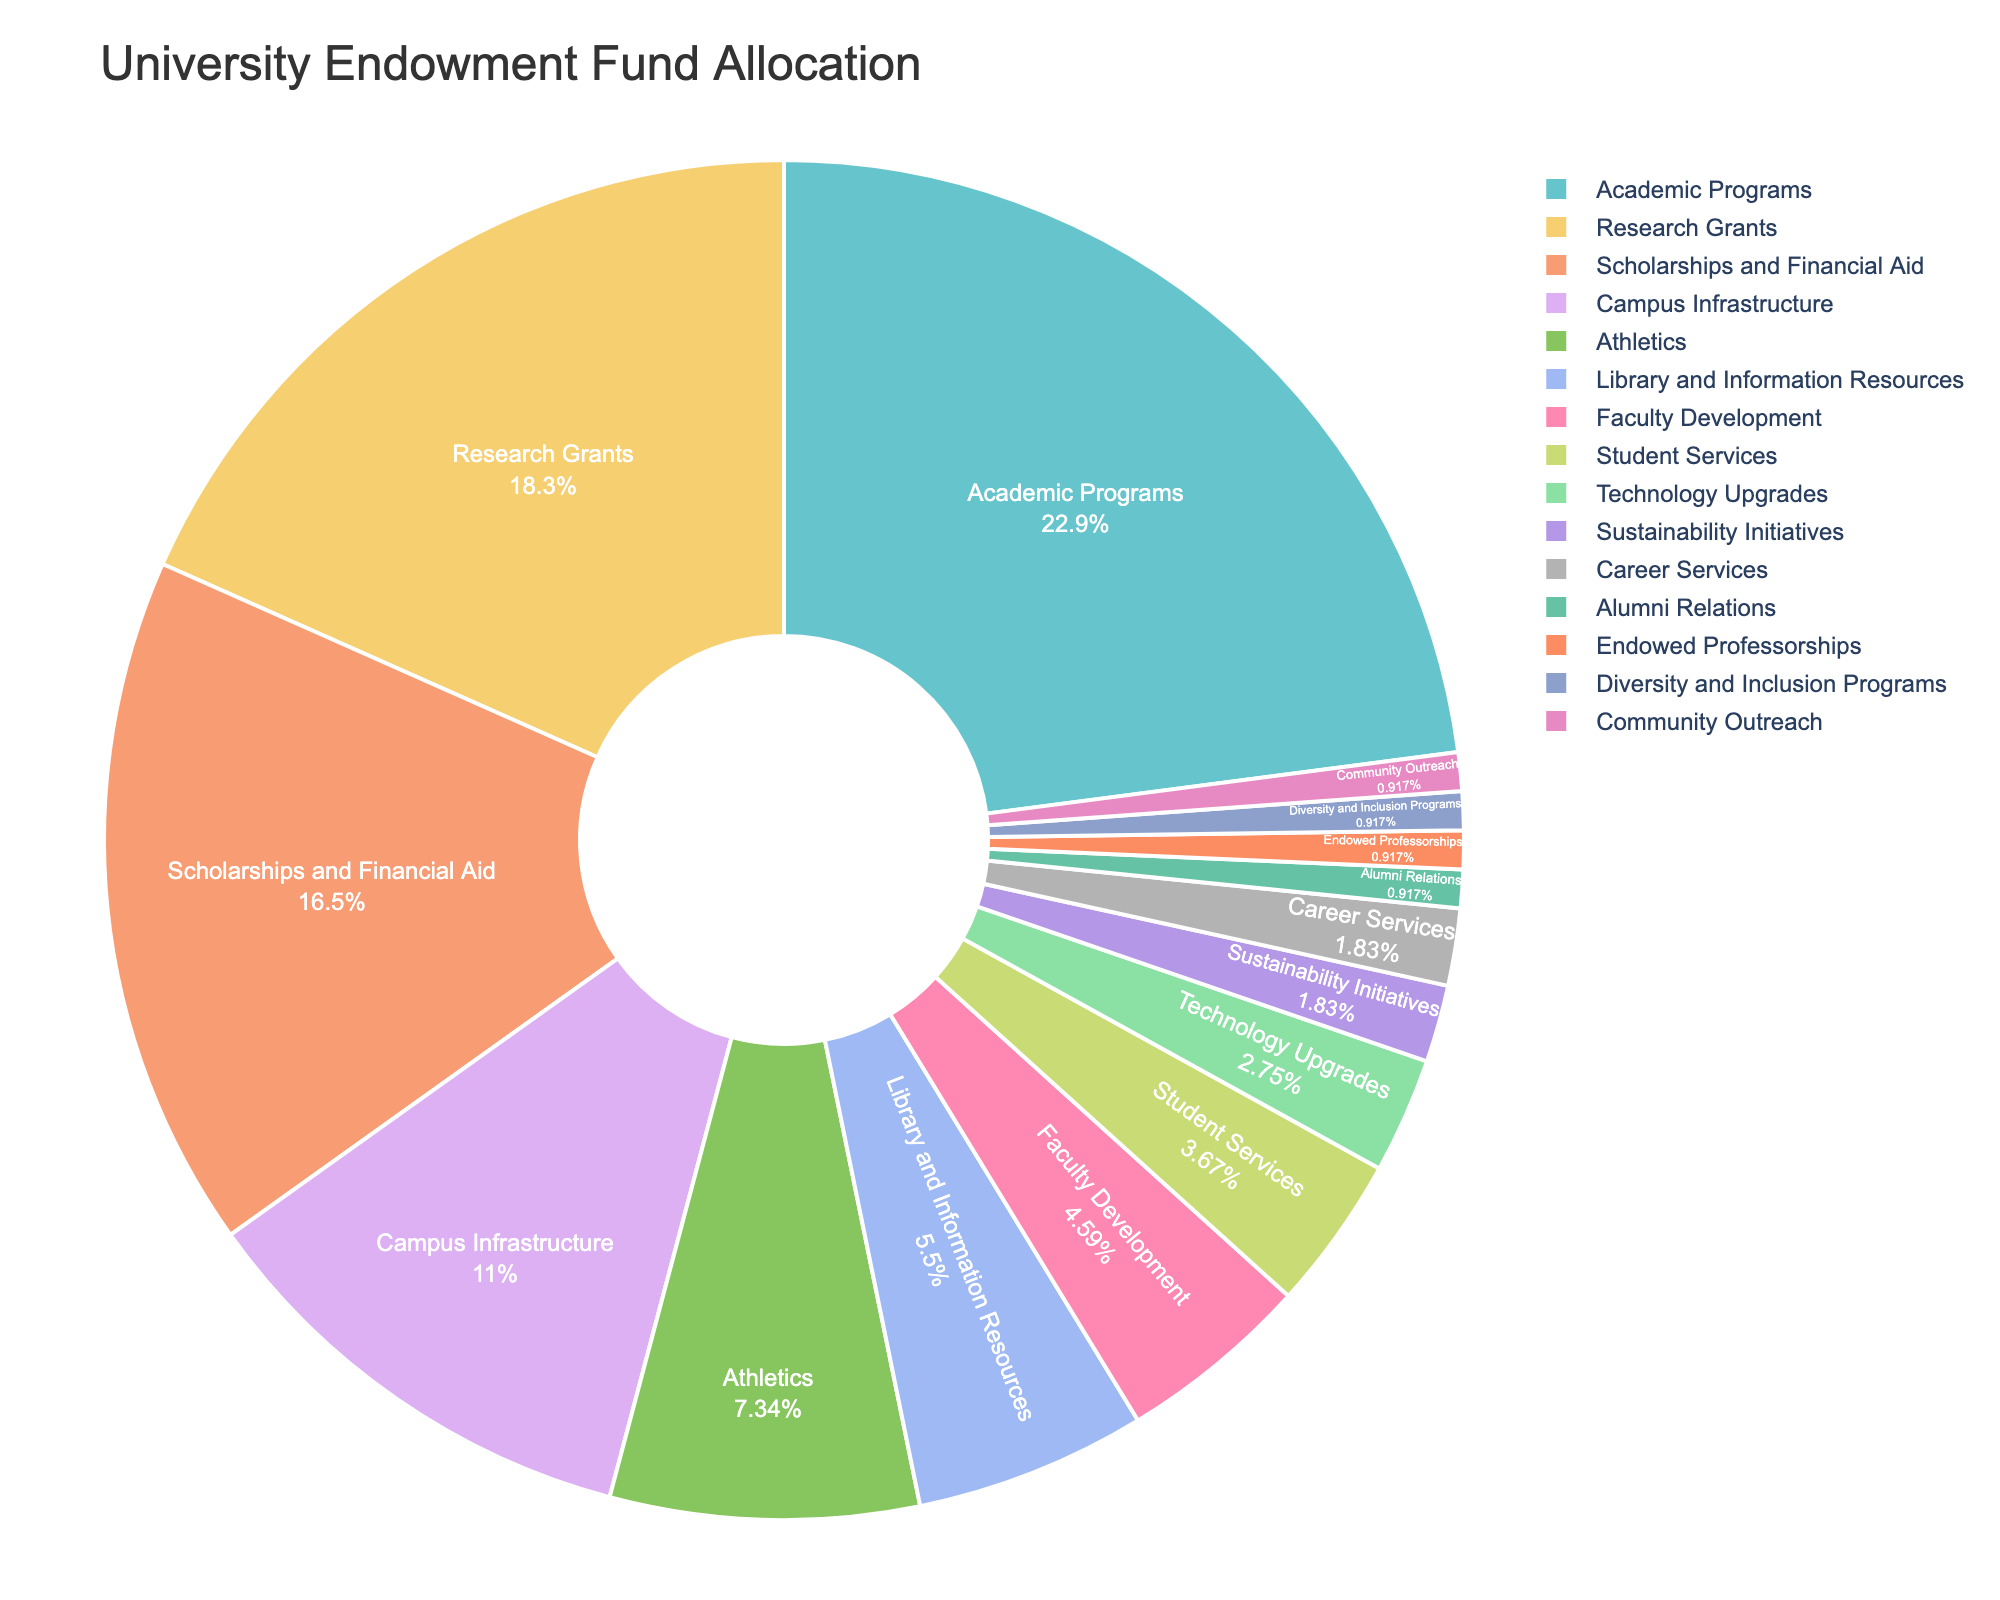Which department/initiative receives the largest portion of funding? The chart shows Academic Programs receiving the largest portion of funding. By size, it occupies the biggest segment in the pie chart.
Answer: Academic Programs How much more funding percentage does Research Grants receive compared to Faculty Development? Research Grants receive 20% while Faculty Development receives 5%. The difference is 20% - 5% = 15%.
Answer: 15% What is the combined percentage allocated to Campus Infrastructure and Athletics? Campus Infrastructure receives 12% and Athletics receives 8%. Their combined allocation is 12% + 8% = 20%.
Answer: 20% Which departments/initiatives have less than 5% allocation each? The segments that are less than 5% are Faculty Development (5%), Student Services (4%), Technology Upgrades (3%), Sustainability Initiatives (2%), Career Services (2%), Alumni Relations (1%), Endowed Professorships (1%), Diversity and Inclusion Programs (1%), and Community Outreach (1%).
Answer: 9 departments/initiatives Is the percentage of funding for Scholarships and Financial Aid greater than the sum of that for Sustainability Initiatives, Career Services, and Alumni Relations? Scholarships and Financial Aid receive 18%. Summing up Sustainability Initiatives (2%), Career Services (2%), and Alumni Relations (1%) results in 5%. Since 18% > 5%, the allocation for Scholarships and Financial Aid is indeed greater.
Answer: Yes What fraction of the total allocation does Student Services represent, and is it smaller or larger than the fraction allocated to Technology Upgrades? Student Services represents 4%, and Technology Upgrades represent 3%. 4% is expressed as 4/100 or 1/25 and 3% is 3/100 or 3/100. Thus, 4% is larger than 3%.
Answer: Larger Which department/initiative has the smallest allocation, and what is its percentage? The smallest allocations are to initiatives like Alumni Relations, Endowed Professorships, Diversity and Inclusion Programs, and Community Outreach, each receiving 1%.
Answer: Alumni Relations, Endowed Professorships, Diversity and Inclusion Programs, Community Outreach (each 1%) What is the total percentage of funding allocated to Academic Programs, Research Grants, and Scholarships and Financial Aid combined? The allocations are Academic Programs (25%), Research Grants (20%), and Scholarships and Financial Aid (18%). Combined, they total 25% + 20% + 18% = 63%.
Answer: 63% How does the funding for Library and Information Resources compare to that for Technology Upgrades? Library and Information Resources receive 6%, whereas Technology Upgrades receive 3%. Hence, Library and Information Resources get twice the funding of Technology Upgrades.
Answer: Twice as much or 2x 